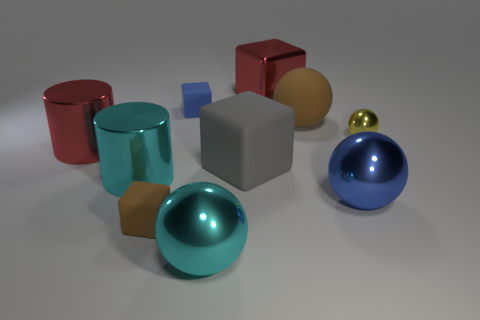Subtract all green cubes. Subtract all red spheres. How many cubes are left? 4 Subtract all yellow balls. How many gray cylinders are left? 0 Add 6 big browns. How many grays exist? 0 Subtract all brown objects. Subtract all small blue matte things. How many objects are left? 7 Add 2 large red blocks. How many large red blocks are left? 3 Add 6 big cyan balls. How many big cyan balls exist? 7 Subtract all cyan spheres. How many spheres are left? 3 Subtract all large brown matte balls. How many balls are left? 3 Subtract 0 purple cylinders. How many objects are left? 10 Subtract all cylinders. How many objects are left? 8 